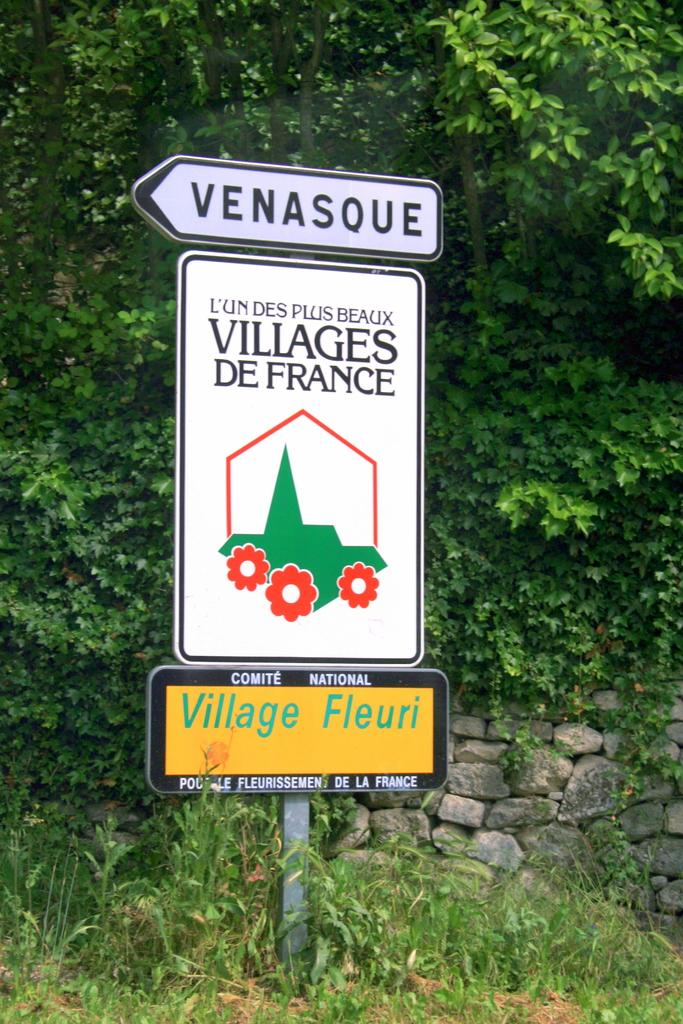What is the main structure in the image? There is a pole with boards in the image. What is depicted on one of the boards? There is an image on one of the boards. What can be seen on the image? Text is written on the image. What is visible in the background of the image? There is a wall and trees in the background of the image. What type of smoke can be seen coming from the scene depicted on the board? There is no smoke present in the image, and the board does not depict a scene. 